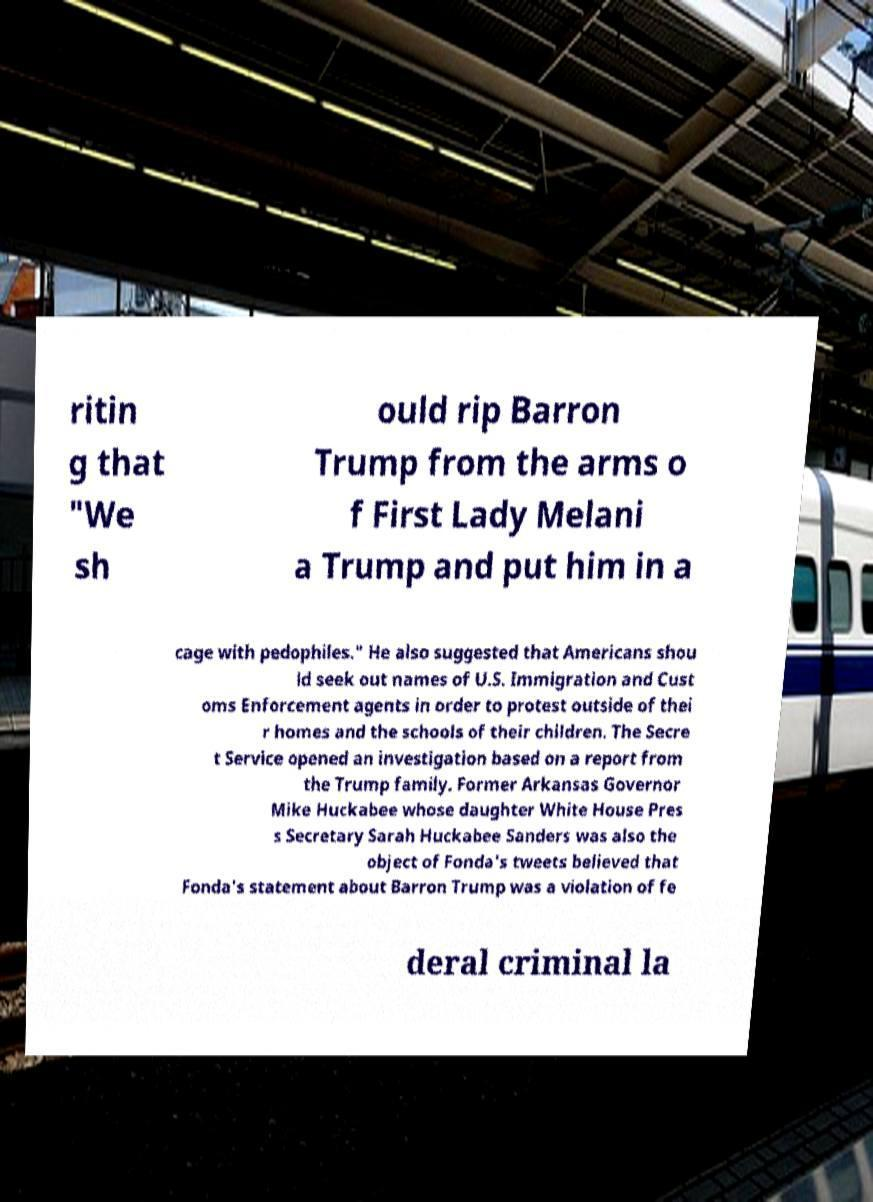Could you assist in decoding the text presented in this image and type it out clearly? ritin g that "We sh ould rip Barron Trump from the arms o f First Lady Melani a Trump and put him in a cage with pedophiles." He also suggested that Americans shou ld seek out names of U.S. Immigration and Cust oms Enforcement agents in order to protest outside of thei r homes and the schools of their children. The Secre t Service opened an investigation based on a report from the Trump family. Former Arkansas Governor Mike Huckabee whose daughter White House Pres s Secretary Sarah Huckabee Sanders was also the object of Fonda's tweets believed that Fonda's statement about Barron Trump was a violation of fe deral criminal la 